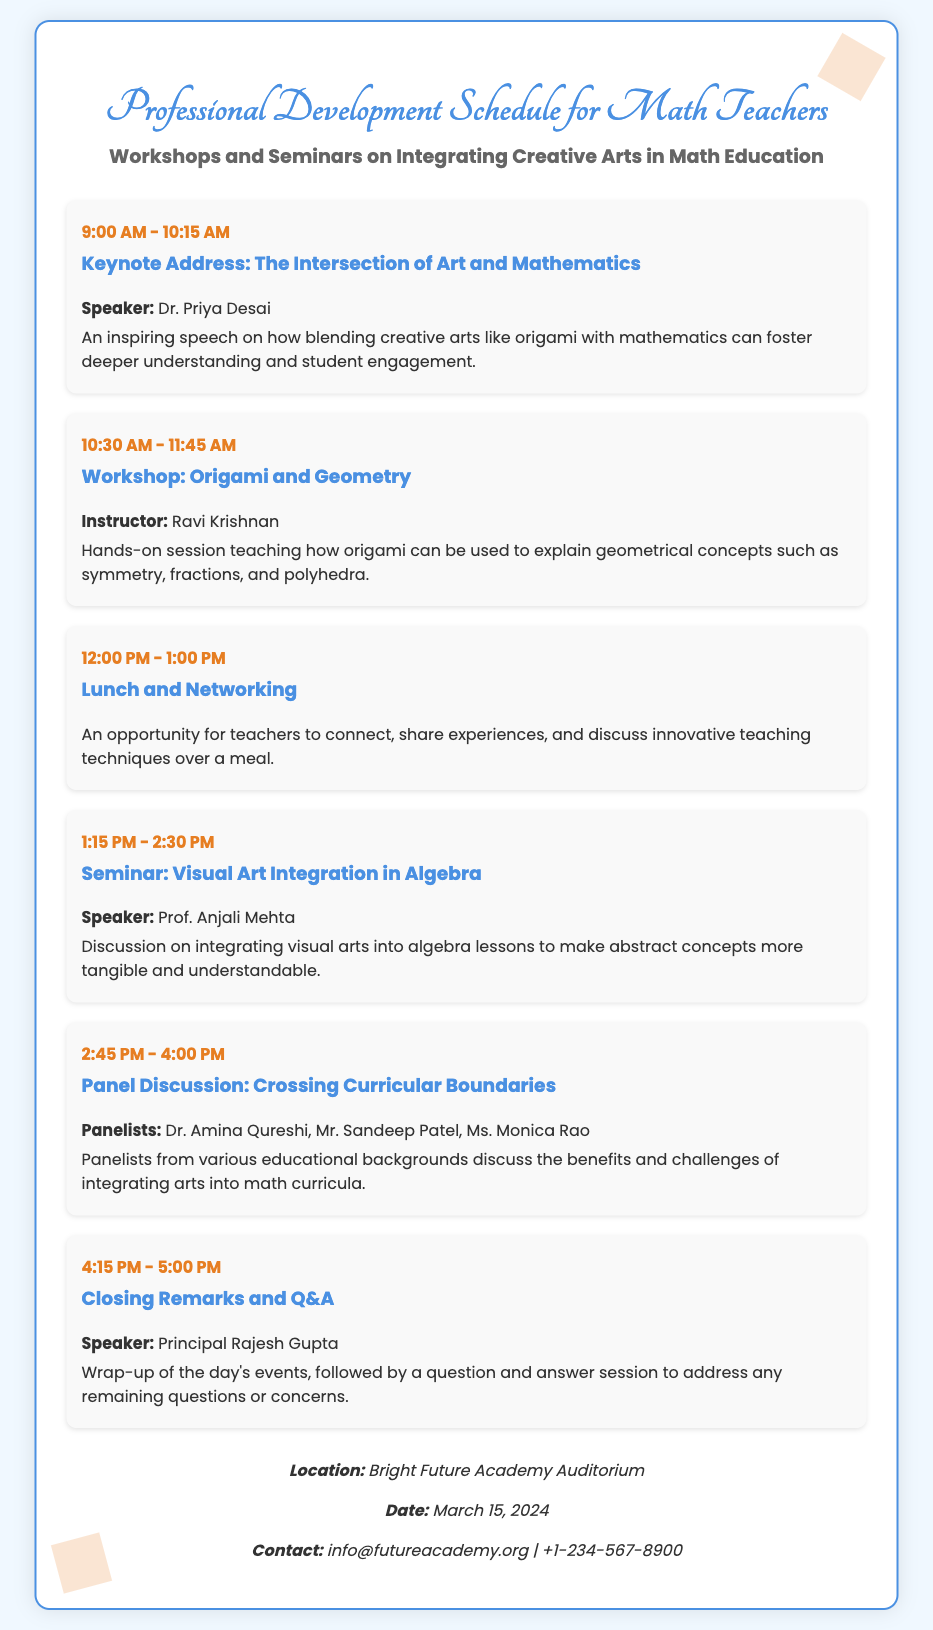What time does the Keynote Address start? The start time for the Keynote Address is stated in the schedule as 9:00 AM.
Answer: 9:00 AM Who is speaking at the workshop on Origami and Geometry? The instructor for the workshop is Ravi Krishnan, as mentioned in the document.
Answer: Ravi Krishnan What is the location of the event? The location is specified as Bright Future Academy Auditorium in the additional info section.
Answer: Bright Future Academy Auditorium What is the date of the professional development schedule? The date for the event is clearly mentioned in the additional info section as March 15, 2024.
Answer: March 15, 2024 What are the names of the panelists in the discussion? The panelists listed for the discussion are Dr. Amina Qureshi, Mr. Sandeep Patel, and Ms. Monica Rao.
Answer: Dr. Amina Qureshi, Mr. Sandeep Patel, Ms. Monica Rao How long is the lunch and networking break? The lunch and networking session is scheduled for one hour, from 12:00 PM to 1:00 PM.
Answer: One hour What is the topic of the closing remarks? The closing remarks include a wrap-up of the day's events followed by a Q&A session, as described at the end of the event schedule.
Answer: Wrap-up and Q&A What kind of session is the 10:30 AM event? The session scheduled for 10:30 AM is a hands-on workshop, specifically focused on Origami and Geometry.
Answer: Workshop 